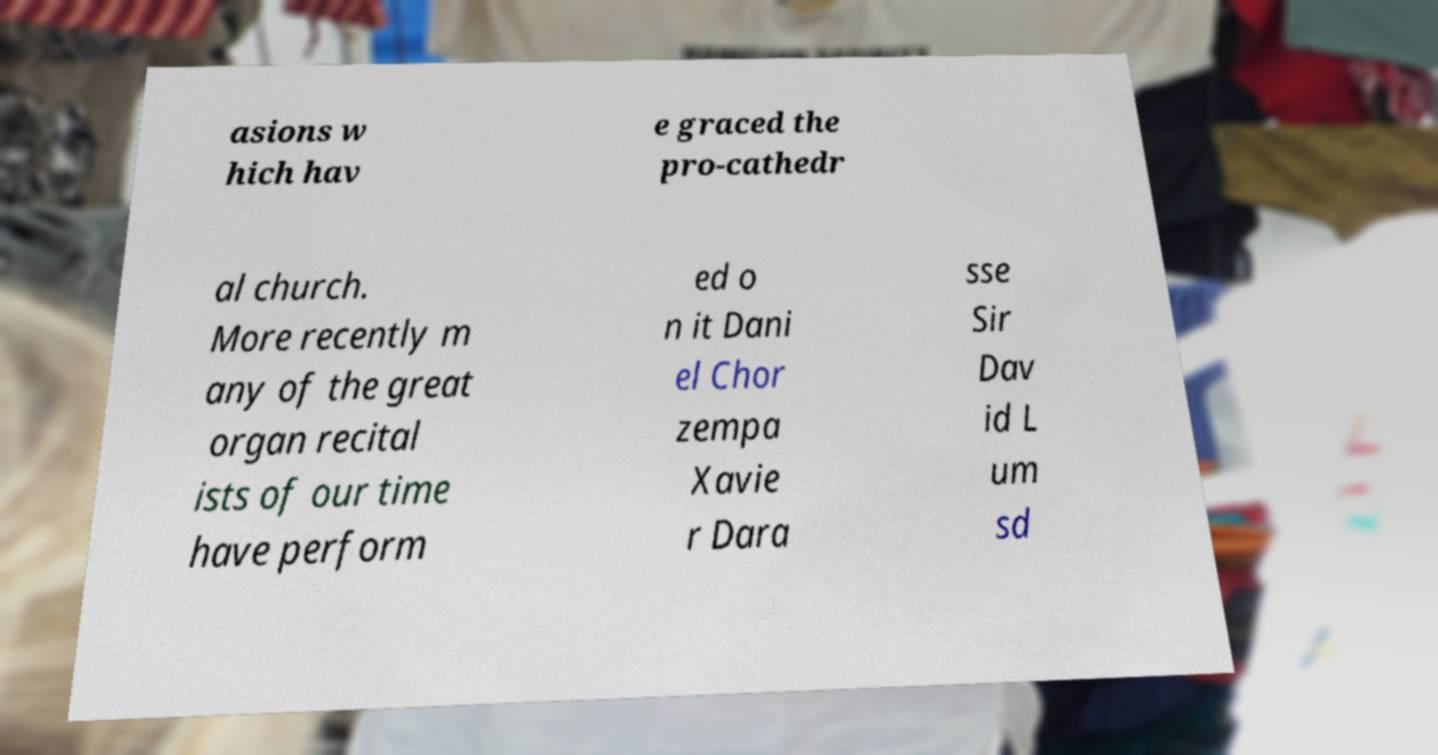Can you read and provide the text displayed in the image?This photo seems to have some interesting text. Can you extract and type it out for me? asions w hich hav e graced the pro-cathedr al church. More recently m any of the great organ recital ists of our time have perform ed o n it Dani el Chor zempa Xavie r Dara sse Sir Dav id L um sd 